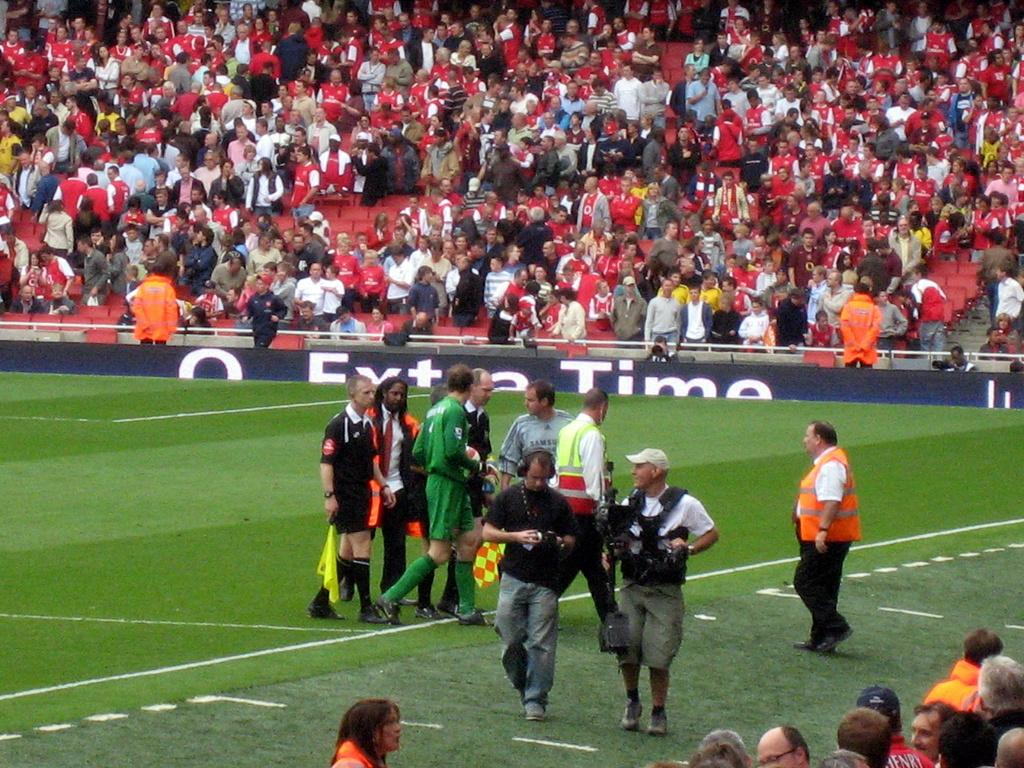<image>
Present a compact description of the photo's key features. A sign that says Extra Time is at the edge of this sports field. 